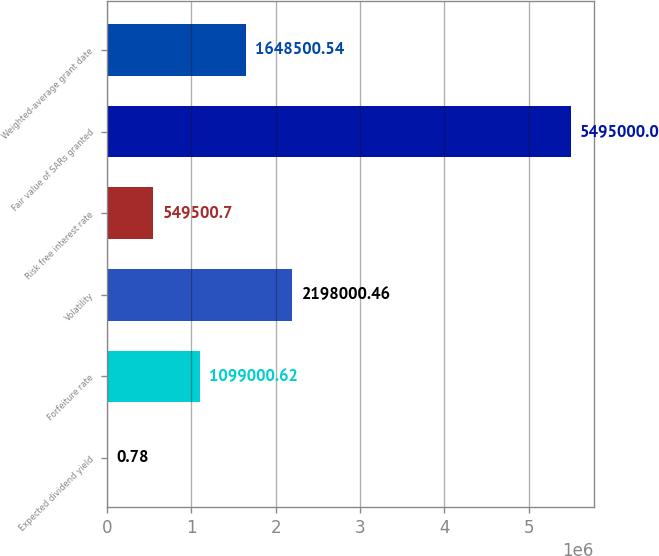Convert chart. <chart><loc_0><loc_0><loc_500><loc_500><bar_chart><fcel>Expected dividend yield<fcel>Forfeiture rate<fcel>Volatility<fcel>Risk free interest rate<fcel>Fair value of SARs granted<fcel>Weighted-average grant date<nl><fcel>0.78<fcel>1.099e+06<fcel>2.198e+06<fcel>549501<fcel>5.495e+06<fcel>1.6485e+06<nl></chart> 